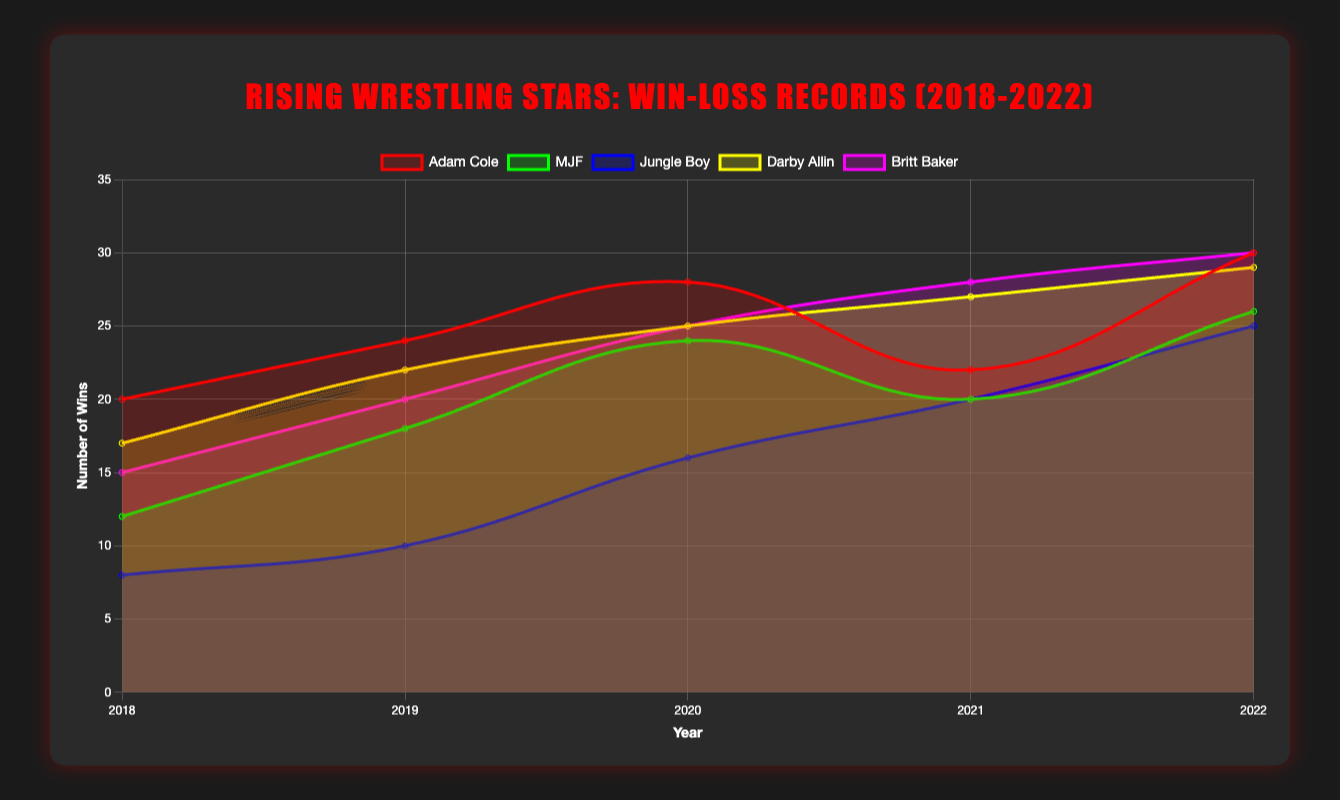Which wrestler had the highest number of wins in 2022? To find this, look at the win counts for all wrestlers in the year 2022 on the line chart and identify the highest value. Adam Cole and Britt Baker both have 30 wins, which is the highest.
Answer: Adam Cole and Britt Baker How many total wins did Adam Cole have from 2018 to 2022? Sum the wins for Adam Cole over the years 2018 to 2022: 20 (2018) + 24 (2019) + 28 (2020) + 22 (2021) + 30 (2022).
Answer: 124 What is the average number of wins for MJF across all the years shown? Add MJF's wins for each year and then divide by the number of years: (12 + 18 + 24 + 20 + 26)/5.
Answer: 20 Between Jungle Boy and Darby Allin, who had more wins in 2021? Check the 2021 data points for Jungle Boy and Darby Allin, and compare their win counts. Jungle Boy has 20 wins, and Darby Allin has 27 wins.
Answer: Darby Allin Whose number of wins increased the most between 2018 and 2022? Calculate the difference in wins between 2022 and 2018 for each wrestler and identify the highest increase: Adam Cole (30-20=10), MJF (26-12=14), Jungle Boy (25-8=17), Darby Allin (29-17=12), Britt Baker (30-15=15).
Answer: Jungle Boy Which wrestler had the most consistent winning record, with the least fluctuation from year to year? Examine the trend lines for each wrestler and assess the stability in win counts over the years. MJF's win record appears to have the least fluctuation.
Answer: MJF What was the difference in the number of wins between Britt Baker and Jungle Boy in 2020? Compare Britt Baker's 25 wins to Jungle Boy's 16 wins in 2020, then subtract the smaller count from the larger.
Answer: 9 Who had a higher win percentage in 2022, Adam Cole or MJF? Calculate the win percentage by dividing wins by the sum of wins and losses: Adam Cole (30/(30+14) ≈ 68.18%), MJF (26/(26+1) ≈ 96.30%).
Answer: MJF 